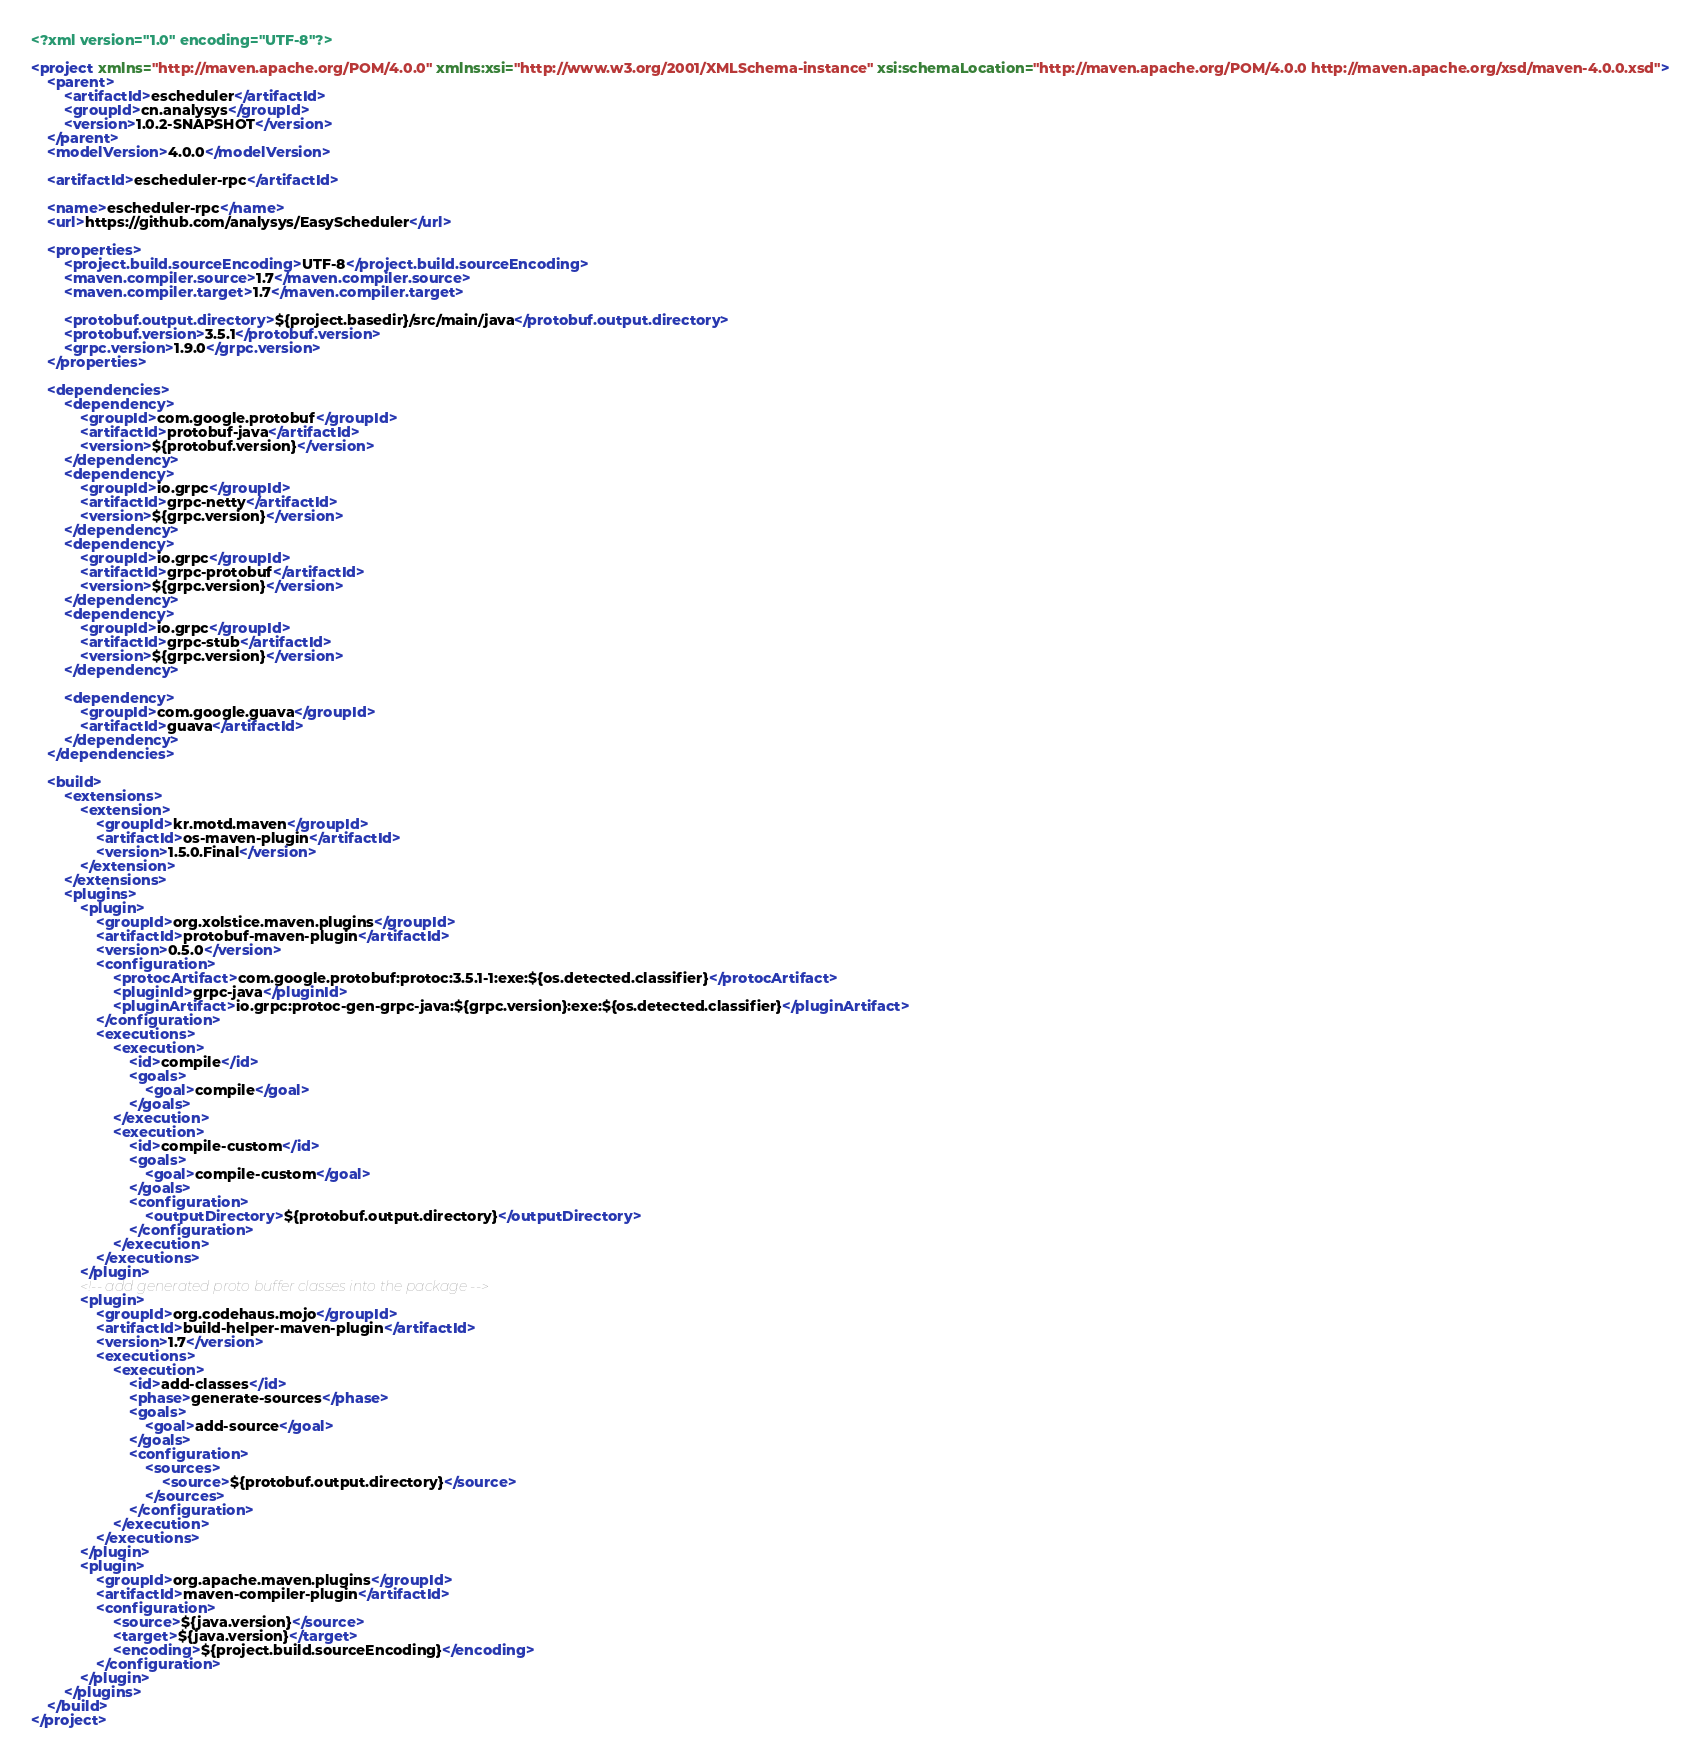Convert code to text. <code><loc_0><loc_0><loc_500><loc_500><_XML_><?xml version="1.0" encoding="UTF-8"?>

<project xmlns="http://maven.apache.org/POM/4.0.0" xmlns:xsi="http://www.w3.org/2001/XMLSchema-instance" xsi:schemaLocation="http://maven.apache.org/POM/4.0.0 http://maven.apache.org/xsd/maven-4.0.0.xsd">
    <parent>
        <artifactId>escheduler</artifactId>
        <groupId>cn.analysys</groupId>
        <version>1.0.2-SNAPSHOT</version>
    </parent>
    <modelVersion>4.0.0</modelVersion>

    <artifactId>escheduler-rpc</artifactId>

    <name>escheduler-rpc</name>
    <url>https://github.com/analysys/EasyScheduler</url>

    <properties>
        <project.build.sourceEncoding>UTF-8</project.build.sourceEncoding>
        <maven.compiler.source>1.7</maven.compiler.source>
        <maven.compiler.target>1.7</maven.compiler.target>

        <protobuf.output.directory>${project.basedir}/src/main/java</protobuf.output.directory>
        <protobuf.version>3.5.1</protobuf.version>
        <grpc.version>1.9.0</grpc.version>
    </properties>

    <dependencies>
        <dependency>
            <groupId>com.google.protobuf</groupId>
            <artifactId>protobuf-java</artifactId>
            <version>${protobuf.version}</version>
        </dependency>
        <dependency>
            <groupId>io.grpc</groupId>
            <artifactId>grpc-netty</artifactId>
            <version>${grpc.version}</version>
        </dependency>
        <dependency>
            <groupId>io.grpc</groupId>
            <artifactId>grpc-protobuf</artifactId>
            <version>${grpc.version}</version>
        </dependency>
        <dependency>
            <groupId>io.grpc</groupId>
            <artifactId>grpc-stub</artifactId>
            <version>${grpc.version}</version>
        </dependency>

        <dependency>
            <groupId>com.google.guava</groupId>
            <artifactId>guava</artifactId>
        </dependency>
    </dependencies>

    <build>
        <extensions>
            <extension>
                <groupId>kr.motd.maven</groupId>
                <artifactId>os-maven-plugin</artifactId>
                <version>1.5.0.Final</version>
            </extension>
        </extensions>
        <plugins>
            <plugin>
                <groupId>org.xolstice.maven.plugins</groupId>
                <artifactId>protobuf-maven-plugin</artifactId>
                <version>0.5.0</version>
                <configuration>
                    <protocArtifact>com.google.protobuf:protoc:3.5.1-1:exe:${os.detected.classifier}</protocArtifact>
                    <pluginId>grpc-java</pluginId>
                    <pluginArtifact>io.grpc:protoc-gen-grpc-java:${grpc.version}:exe:${os.detected.classifier}</pluginArtifact>
                </configuration>
                <executions>
                    <execution>
                        <id>compile</id>
                        <goals>
                            <goal>compile</goal>
                        </goals>
                    </execution>
                    <execution>
                        <id>compile-custom</id>
                        <goals>
                            <goal>compile-custom</goal>
                        </goals>
                        <configuration>
                            <outputDirectory>${protobuf.output.directory}</outputDirectory>
                        </configuration>
                    </execution>
                </executions>
            </plugin>
            <!-- add generated proto buffer classes into the package -->
            <plugin>
                <groupId>org.codehaus.mojo</groupId>
                <artifactId>build-helper-maven-plugin</artifactId>
                <version>1.7</version>
                <executions>
                    <execution>
                        <id>add-classes</id>
                        <phase>generate-sources</phase>
                        <goals>
                            <goal>add-source</goal>
                        </goals>
                        <configuration>
                            <sources>
                                <source>${protobuf.output.directory}</source>
                            </sources>
                        </configuration>
                    </execution>
                </executions>
            </plugin>
            <plugin>
                <groupId>org.apache.maven.plugins</groupId>
                <artifactId>maven-compiler-plugin</artifactId>
                <configuration>
                    <source>${java.version}</source>
                    <target>${java.version}</target>
                    <encoding>${project.build.sourceEncoding}</encoding>
                </configuration>
            </plugin>
        </plugins>
    </build>
</project>
</code> 